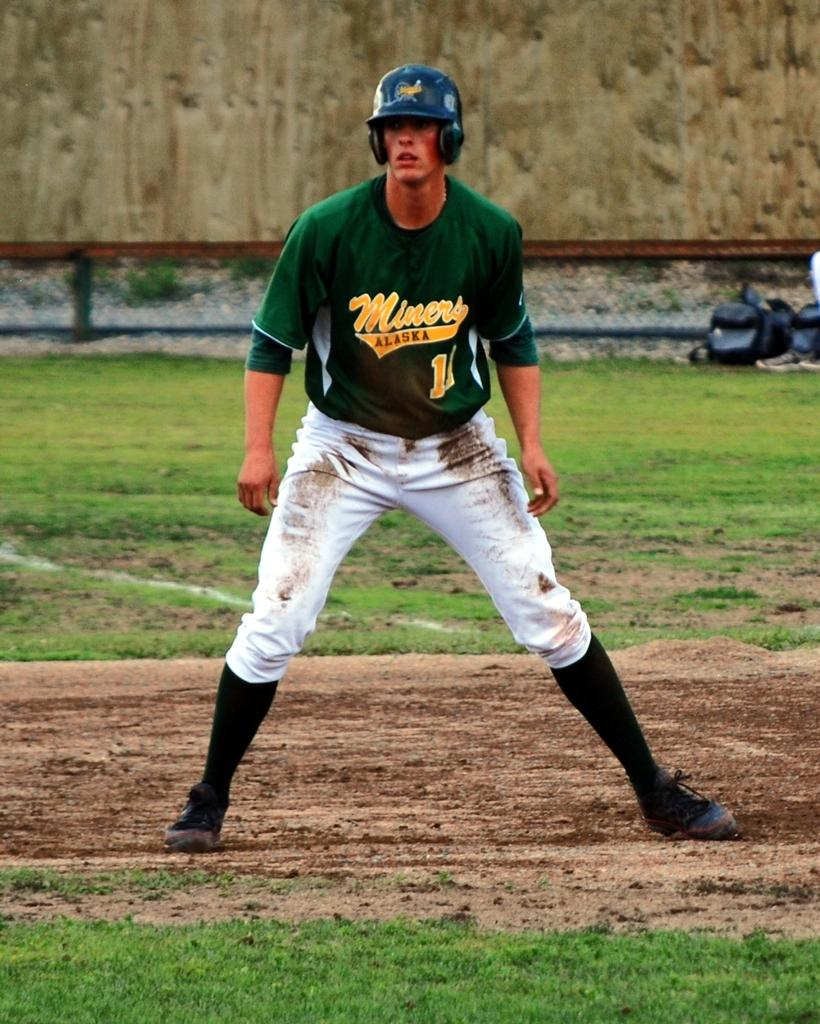<image>
Provide a brief description of the given image. A man in a Miners jersey is stretching away from the base. 